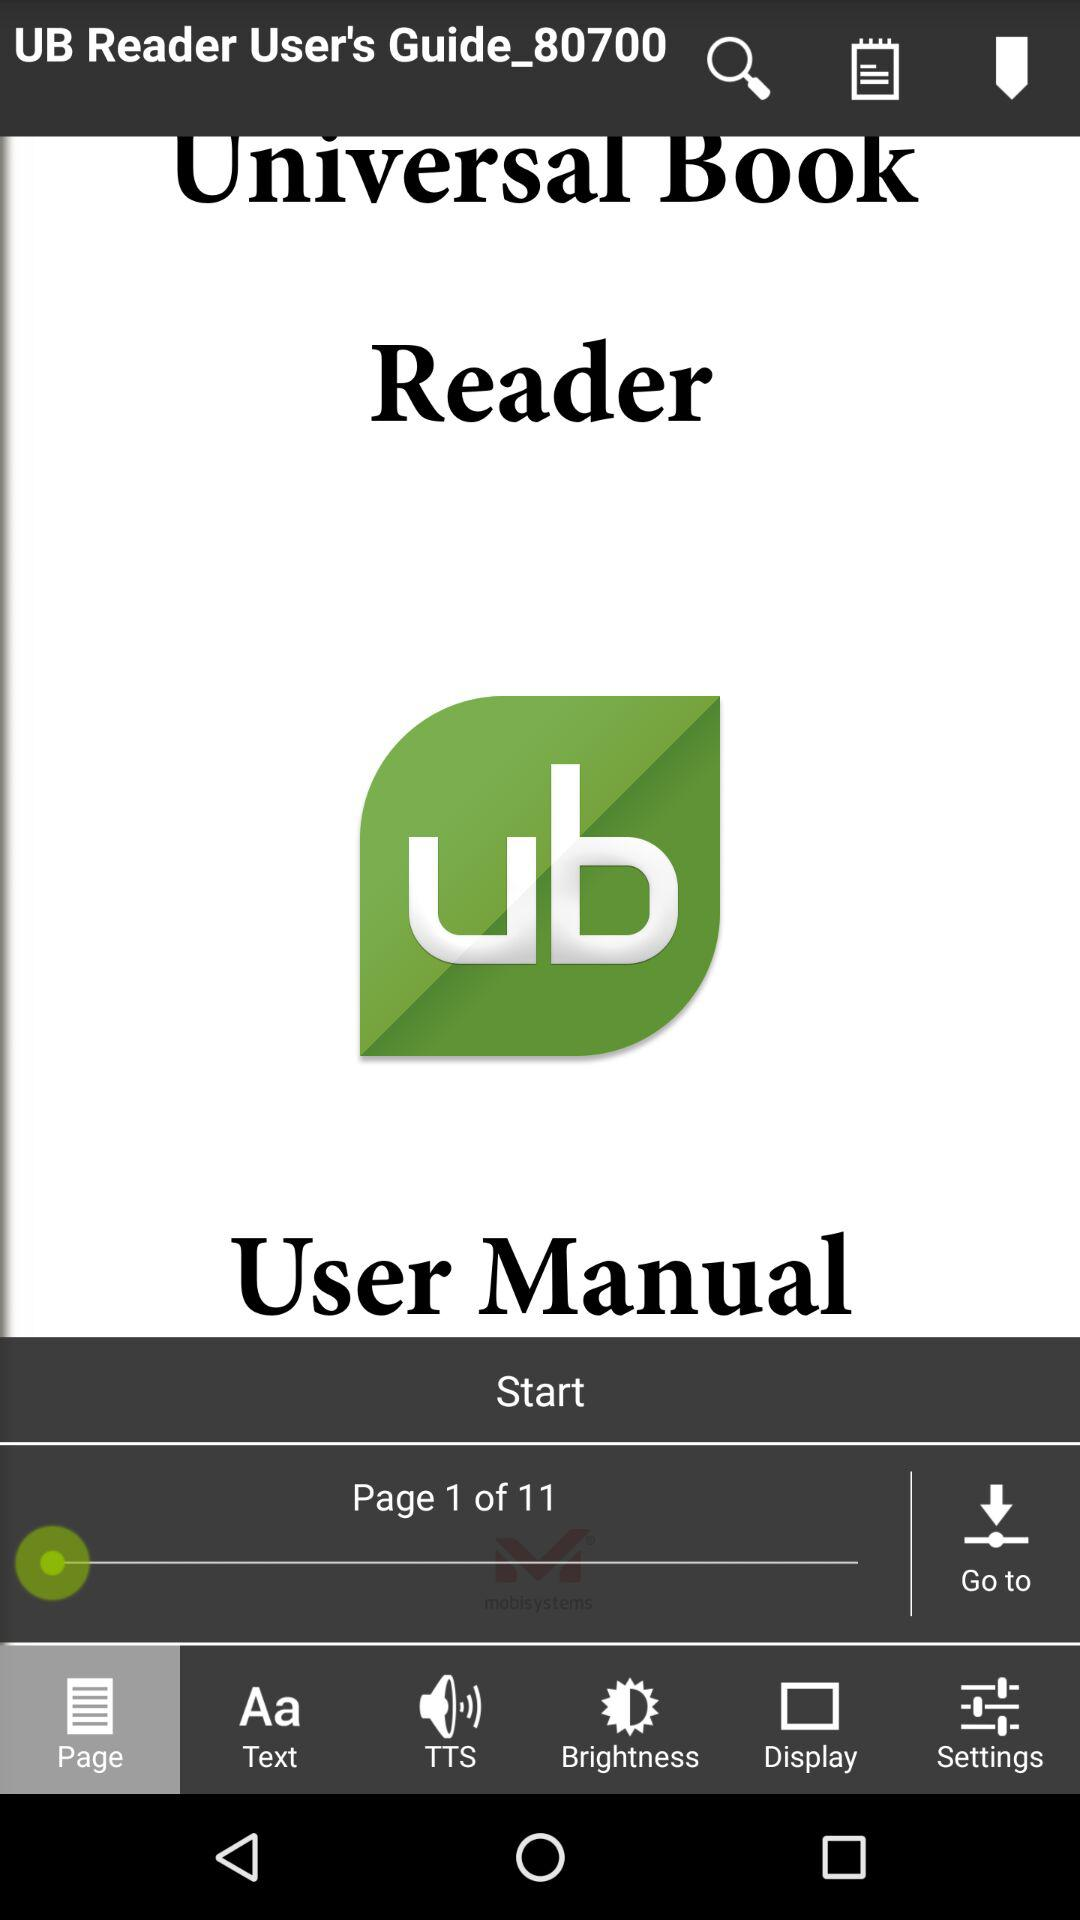What is the application name? The application name is "Universal Book Reader". 